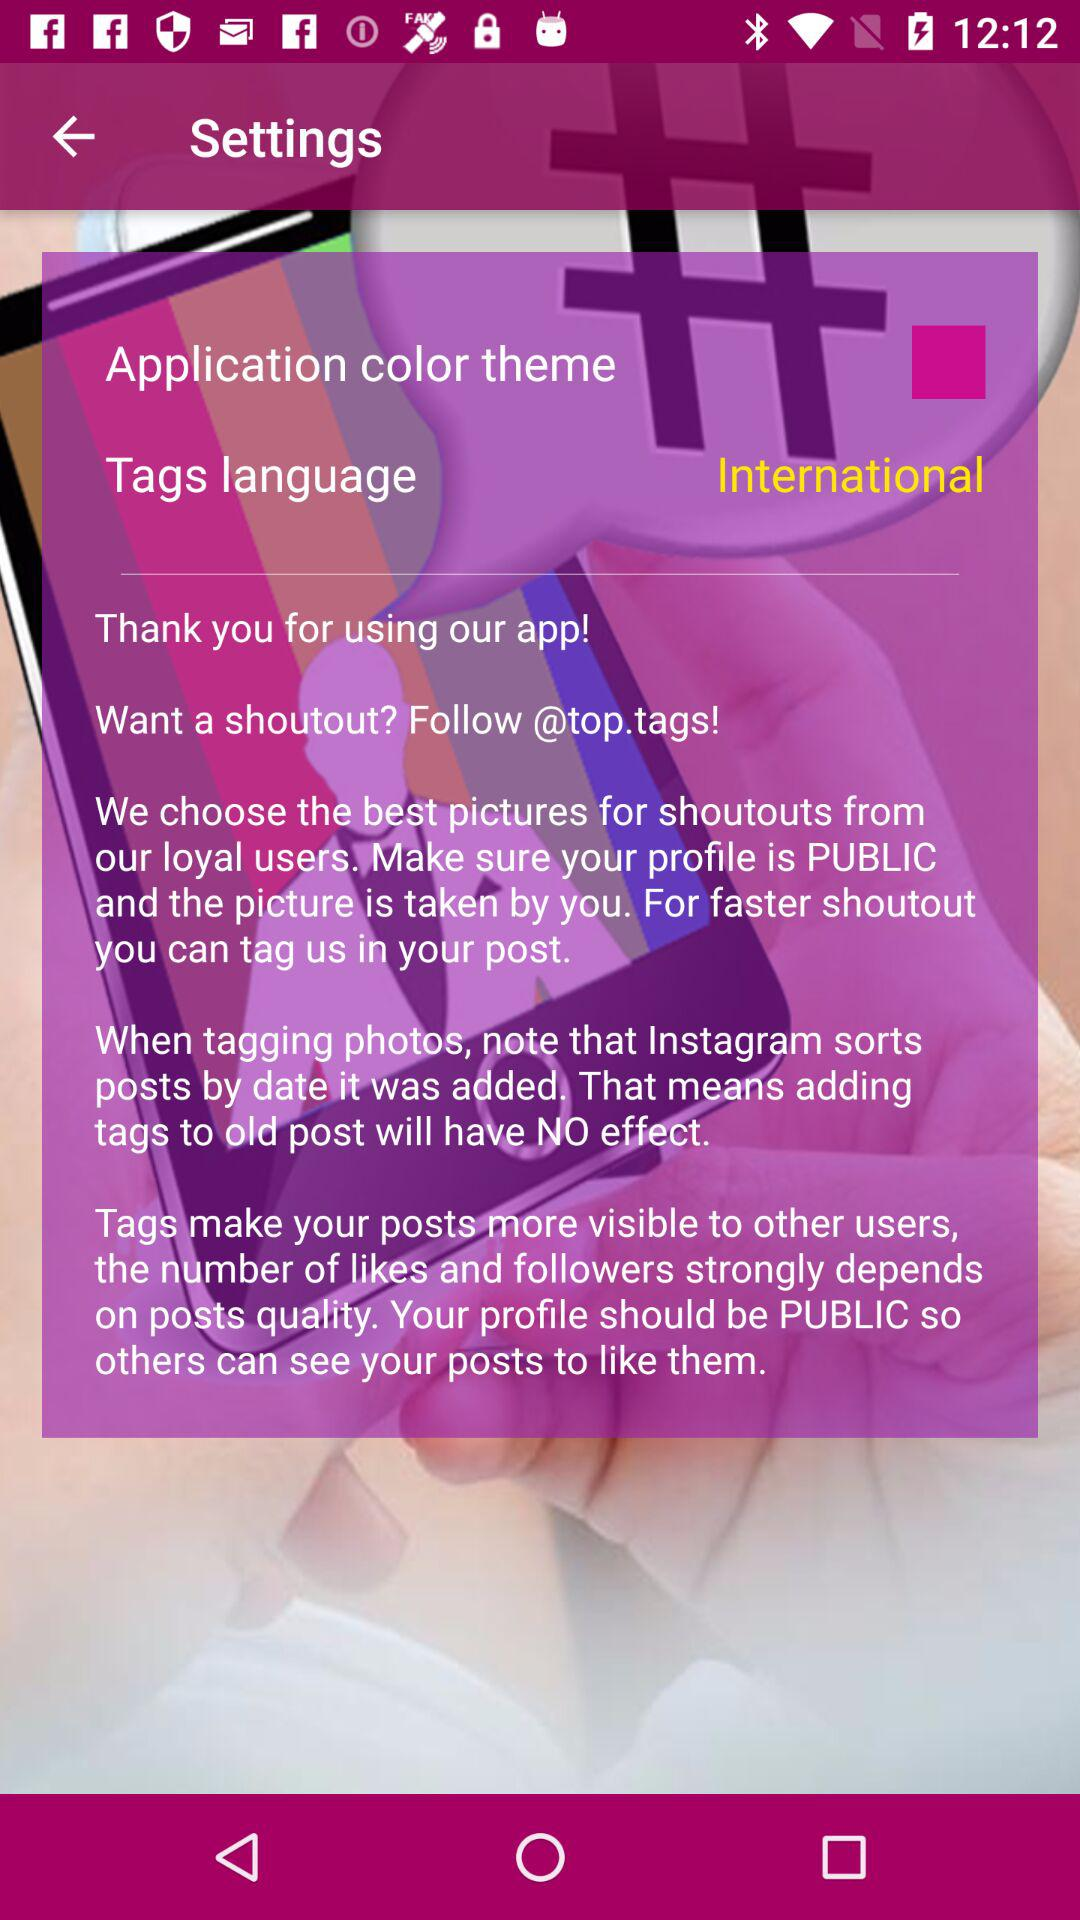What's the "Tags language"? The "Tags language" is international. 